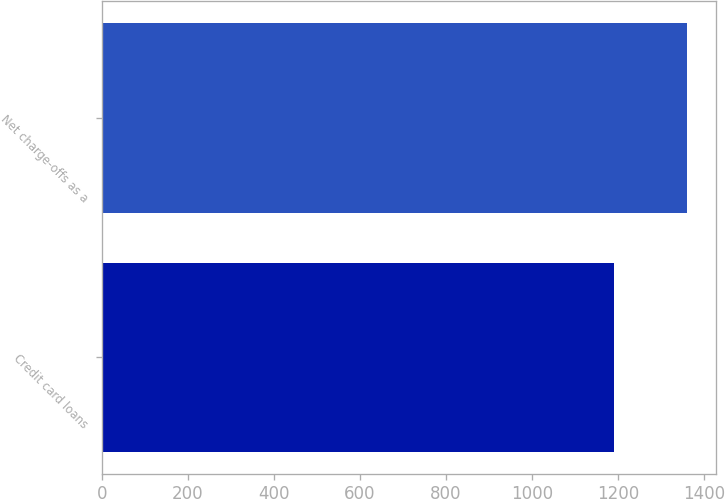Convert chart to OTSL. <chart><loc_0><loc_0><loc_500><loc_500><bar_chart><fcel>Credit card loans<fcel>Net charge-offs as a<nl><fcel>1191<fcel>1360.4<nl></chart> 